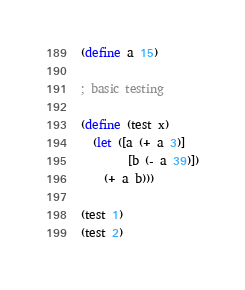Convert code to text. <code><loc_0><loc_0><loc_500><loc_500><_Racket_>(define a 15)

; basic testing

(define (test x)
  (let ([a (+ a 3)]
        [b (- a 39)])
    (+ a b)))

(test 1)
(test 2)
</code> 